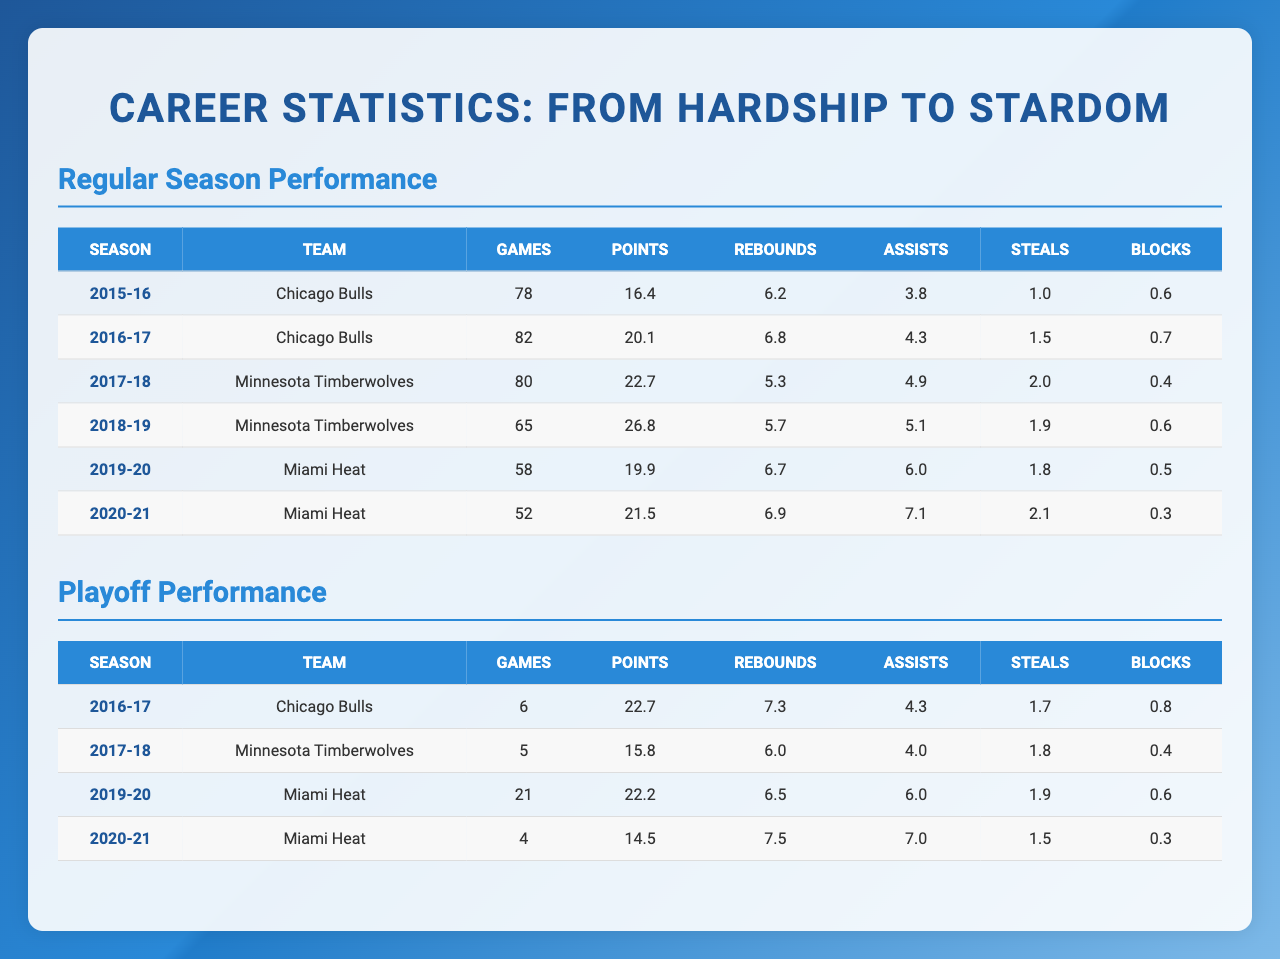What was the highest points per game in a regular season? The highest points per game can be found in the "Points" column of the "Regular Season" section. The season with the highest points per game is 2018-19 with 26.8 points.
Answer: 26.8 Which team did you play for in the 2016-17 season? The "Team" column in the "Regular Season" section shows that in the 2016-17 season, you played for the Chicago Bulls.
Answer: Chicago Bulls What is the total number of games played in the playoffs across all seasons? To find the total games played, sum the "Games" column in the "Playoffs" section: 6 + 5 + 21 + 4 = 36.
Answer: 36 How many total rebounds did you average in the regular season over your career? First, sum the rebounds from each regular season: 6.2 + 6.8 + 5.3 + 5.7 + 6.7 + 6.9 = 37.6. Then divide by the number of seasons (6) to find the average: 37.6 / 6 = 6.27.
Answer: 6.27 Did you play more playoff games in 2019-20 or in 2020-21? Looking at the "Games" column in the playoffs, in 2019-20 you played 21 games, while in 2020-21 you played only 4 games. Since 21 is greater than 4, you played more games in 2019-20.
Answer: Yes, more in 2019-20 What was your average points per game in the playoffs during the 2020-21 season? In the "Playoffs" section, for the 2020-21 season, the points per game recorded was 14.5. There are no additional statistics needed since this is a direct retrieval from the table.
Answer: 14.5 Which season had the highest assists per game in the regular season? Check the "Assists" column in the "Regular Season" section: 7.1 in 2020-21 is the highest. Therefore, 2020-21 had the most assists per game.
Answer: 2020-21 What is the difference in average points per game between the regular season and playoffs for the 2016-17 season? In the regular season 2016-17, points per game were 20.1. In the playoffs, it was 22.7. The difference is 22.7 - 20.1 = 2.6.
Answer: 2.6 Did your points per game increase from the regular season to the playoffs in 2019-20? In the "Regular Season" for 2019-20, points per game were 19.9, while in playoffs it was 22.2. Since 22.2 is greater than 19.9, there was an increase.
Answer: Yes, it increased Which season had the lowest total number of games played in the regular season? Review the "Games" column in the regular season: 52 games in the 2020-21 season is the lowest.
Answer: 2020-21 What was the average number of steals per game in the regular season over your career? Sum the steals: 1.0 + 1.5 + 2.0 + 1.9 + 1.8 + 2.1 = 10.3, and then divide by 6 (the number of seasons): 10.3 / 6 = 1.716.
Answer: 1.72 